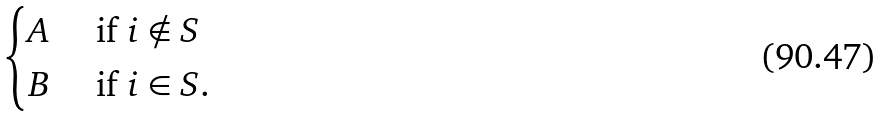Convert formula to latex. <formula><loc_0><loc_0><loc_500><loc_500>\begin{cases} A & \ \text {if} \ i \notin S \\ B & \ \text {if} \ i \in S . \end{cases}</formula> 